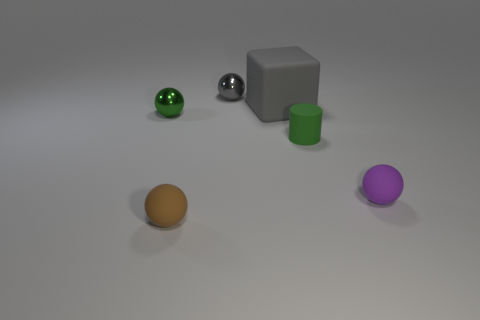How many rubber objects are brown things or small things?
Provide a short and direct response. 3. What number of large matte objects are there?
Ensure brevity in your answer.  1. Is the material of the green thing on the left side of the brown matte thing the same as the green object in front of the green shiny thing?
Offer a very short reply. No. What color is the other tiny shiny object that is the same shape as the small gray object?
Give a very brief answer. Green. There is a tiny green cylinder in front of the tiny green thing on the left side of the tiny brown matte ball; what is it made of?
Give a very brief answer. Rubber. Is the shape of the object that is to the right of the small green matte cylinder the same as the gray rubber object that is on the left side of the cylinder?
Provide a short and direct response. No. There is a sphere that is both behind the purple rubber sphere and to the right of the green metallic sphere; how big is it?
Ensure brevity in your answer.  Small. What number of other things are the same color as the big object?
Offer a very short reply. 1. Is the material of the tiny green object that is behind the rubber cylinder the same as the large block?
Your answer should be compact. No. Is there any other thing that is the same size as the brown matte sphere?
Give a very brief answer. Yes. 